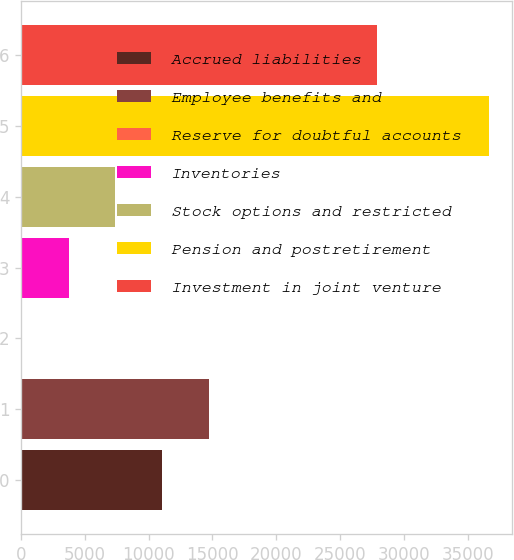<chart> <loc_0><loc_0><loc_500><loc_500><bar_chart><fcel>Accrued liabilities<fcel>Employee benefits and<fcel>Reserve for doubtful accounts<fcel>Inventories<fcel>Stock options and restricted<fcel>Pension and postretirement<fcel>Investment in joint venture<nl><fcel>11041.7<fcel>14703.6<fcel>56<fcel>3717.9<fcel>7379.8<fcel>36675<fcel>27865<nl></chart> 